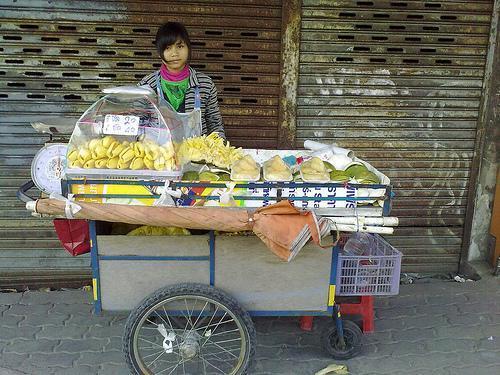How many scales do the girl have?
Give a very brief answer. 1. How many red bags are in the image?
Give a very brief answer. 1. 